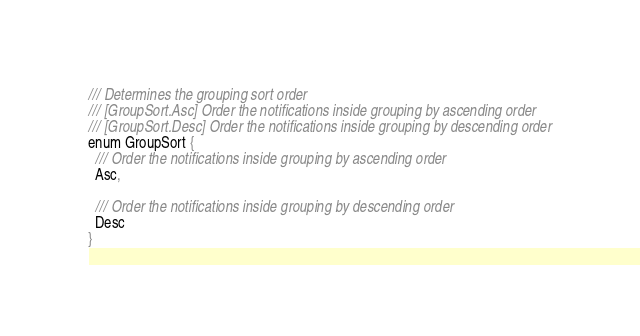<code> <loc_0><loc_0><loc_500><loc_500><_Dart_>/// Determines the grouping sort order
/// [GroupSort.Asc] Order the notifications inside grouping by ascending order
/// [GroupSort.Desc] Order the notifications inside grouping by descending order
enum GroupSort {
  /// Order the notifications inside grouping by ascending order
  Asc,

  /// Order the notifications inside grouping by descending order
  Desc
}
</code> 